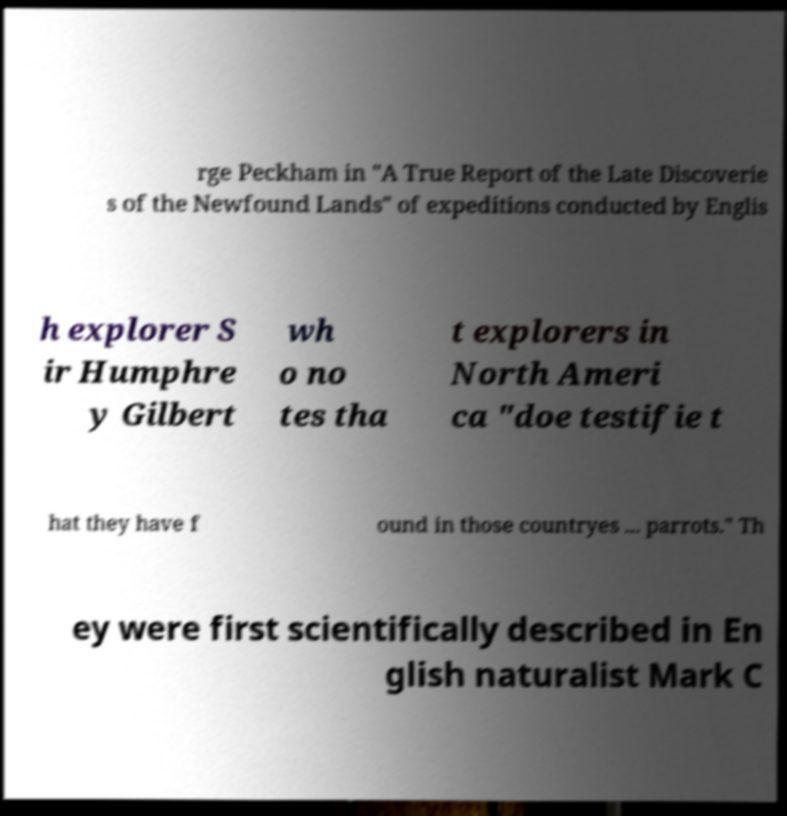I need the written content from this picture converted into text. Can you do that? rge Peckham in "A True Report of the Late Discoverie s of the Newfound Lands" of expeditions conducted by Englis h explorer S ir Humphre y Gilbert wh o no tes tha t explorers in North Ameri ca "doe testifie t hat they have f ound in those countryes ... parrots." Th ey were first scientifically described in En glish naturalist Mark C 